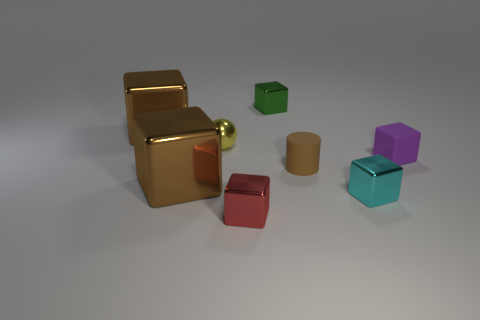Subtract all red cubes. How many cubes are left? 5 Subtract all tiny purple rubber blocks. How many blocks are left? 5 Subtract all gray blocks. Subtract all red cylinders. How many blocks are left? 6 Add 2 tiny brown rubber objects. How many objects exist? 10 Subtract all cubes. How many objects are left? 2 Add 3 red things. How many red things are left? 4 Add 6 big objects. How many big objects exist? 8 Subtract 0 gray balls. How many objects are left? 8 Subtract all metallic blocks. Subtract all red shiny objects. How many objects are left? 2 